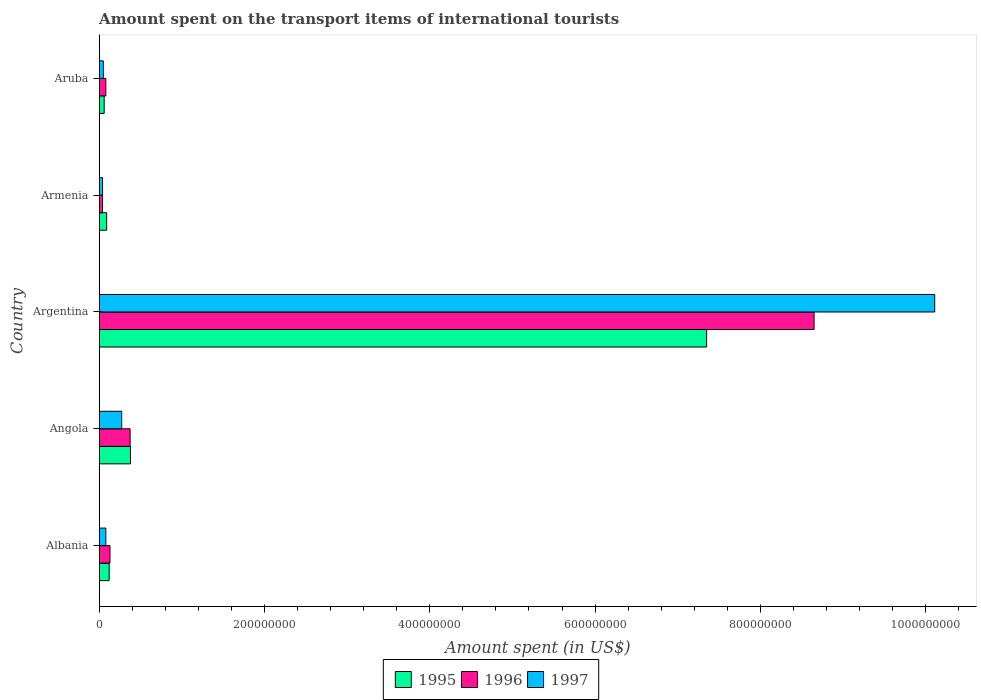How many groups of bars are there?
Offer a very short reply. 5. Are the number of bars per tick equal to the number of legend labels?
Your answer should be compact. Yes. How many bars are there on the 1st tick from the bottom?
Ensure brevity in your answer.  3. What is the label of the 5th group of bars from the top?
Ensure brevity in your answer.  Albania. In how many cases, is the number of bars for a given country not equal to the number of legend labels?
Keep it short and to the point. 0. What is the amount spent on the transport items of international tourists in 1996 in Aruba?
Give a very brief answer. 8.00e+06. Across all countries, what is the maximum amount spent on the transport items of international tourists in 1995?
Your answer should be very brief. 7.35e+08. In which country was the amount spent on the transport items of international tourists in 1995 maximum?
Make the answer very short. Argentina. In which country was the amount spent on the transport items of international tourists in 1997 minimum?
Your answer should be very brief. Armenia. What is the total amount spent on the transport items of international tourists in 1997 in the graph?
Provide a succinct answer. 1.06e+09. What is the average amount spent on the transport items of international tourists in 1997 per country?
Offer a very short reply. 2.11e+08. What is the difference between the amount spent on the transport items of international tourists in 1995 and amount spent on the transport items of international tourists in 1996 in Argentina?
Offer a terse response. -1.30e+08. What is the ratio of the amount spent on the transport items of international tourists in 1996 in Albania to that in Aruba?
Make the answer very short. 1.62. Is the difference between the amount spent on the transport items of international tourists in 1995 in Argentina and Aruba greater than the difference between the amount spent on the transport items of international tourists in 1996 in Argentina and Aruba?
Offer a terse response. No. What is the difference between the highest and the second highest amount spent on the transport items of international tourists in 1995?
Provide a short and direct response. 6.97e+08. What is the difference between the highest and the lowest amount spent on the transport items of international tourists in 1996?
Offer a terse response. 8.61e+08. Does the graph contain any zero values?
Make the answer very short. No. Does the graph contain grids?
Your answer should be compact. No. How are the legend labels stacked?
Offer a very short reply. Horizontal. What is the title of the graph?
Give a very brief answer. Amount spent on the transport items of international tourists. Does "1975" appear as one of the legend labels in the graph?
Make the answer very short. No. What is the label or title of the X-axis?
Your answer should be compact. Amount spent (in US$). What is the label or title of the Y-axis?
Your response must be concise. Country. What is the Amount spent (in US$) of 1995 in Albania?
Ensure brevity in your answer.  1.20e+07. What is the Amount spent (in US$) of 1996 in Albania?
Offer a terse response. 1.30e+07. What is the Amount spent (in US$) in 1997 in Albania?
Offer a terse response. 8.00e+06. What is the Amount spent (in US$) of 1995 in Angola?
Provide a succinct answer. 3.78e+07. What is the Amount spent (in US$) in 1996 in Angola?
Give a very brief answer. 3.74e+07. What is the Amount spent (in US$) in 1997 in Angola?
Offer a very short reply. 2.72e+07. What is the Amount spent (in US$) of 1995 in Argentina?
Give a very brief answer. 7.35e+08. What is the Amount spent (in US$) in 1996 in Argentina?
Keep it short and to the point. 8.65e+08. What is the Amount spent (in US$) in 1997 in Argentina?
Offer a very short reply. 1.01e+09. What is the Amount spent (in US$) in 1995 in Armenia?
Ensure brevity in your answer.  9.00e+06. What is the Amount spent (in US$) of 1996 in Armenia?
Provide a short and direct response. 4.00e+06. What is the Amount spent (in US$) of 1996 in Aruba?
Provide a succinct answer. 8.00e+06. Across all countries, what is the maximum Amount spent (in US$) of 1995?
Offer a very short reply. 7.35e+08. Across all countries, what is the maximum Amount spent (in US$) in 1996?
Provide a succinct answer. 8.65e+08. Across all countries, what is the maximum Amount spent (in US$) in 1997?
Offer a terse response. 1.01e+09. What is the total Amount spent (in US$) of 1995 in the graph?
Ensure brevity in your answer.  8.00e+08. What is the total Amount spent (in US$) in 1996 in the graph?
Provide a succinct answer. 9.27e+08. What is the total Amount spent (in US$) in 1997 in the graph?
Keep it short and to the point. 1.06e+09. What is the difference between the Amount spent (in US$) in 1995 in Albania and that in Angola?
Ensure brevity in your answer.  -2.58e+07. What is the difference between the Amount spent (in US$) in 1996 in Albania and that in Angola?
Ensure brevity in your answer.  -2.44e+07. What is the difference between the Amount spent (in US$) in 1997 in Albania and that in Angola?
Provide a succinct answer. -1.92e+07. What is the difference between the Amount spent (in US$) of 1995 in Albania and that in Argentina?
Ensure brevity in your answer.  -7.23e+08. What is the difference between the Amount spent (in US$) in 1996 in Albania and that in Argentina?
Give a very brief answer. -8.52e+08. What is the difference between the Amount spent (in US$) of 1997 in Albania and that in Argentina?
Your answer should be very brief. -1.00e+09. What is the difference between the Amount spent (in US$) of 1996 in Albania and that in Armenia?
Ensure brevity in your answer.  9.00e+06. What is the difference between the Amount spent (in US$) of 1995 in Angola and that in Argentina?
Ensure brevity in your answer.  -6.97e+08. What is the difference between the Amount spent (in US$) of 1996 in Angola and that in Argentina?
Make the answer very short. -8.28e+08. What is the difference between the Amount spent (in US$) of 1997 in Angola and that in Argentina?
Provide a succinct answer. -9.84e+08. What is the difference between the Amount spent (in US$) of 1995 in Angola and that in Armenia?
Make the answer very short. 2.88e+07. What is the difference between the Amount spent (in US$) in 1996 in Angola and that in Armenia?
Your response must be concise. 3.34e+07. What is the difference between the Amount spent (in US$) of 1997 in Angola and that in Armenia?
Your answer should be very brief. 2.32e+07. What is the difference between the Amount spent (in US$) in 1995 in Angola and that in Aruba?
Your answer should be very brief. 3.18e+07. What is the difference between the Amount spent (in US$) in 1996 in Angola and that in Aruba?
Your answer should be very brief. 2.94e+07. What is the difference between the Amount spent (in US$) in 1997 in Angola and that in Aruba?
Give a very brief answer. 2.22e+07. What is the difference between the Amount spent (in US$) of 1995 in Argentina and that in Armenia?
Make the answer very short. 7.26e+08. What is the difference between the Amount spent (in US$) of 1996 in Argentina and that in Armenia?
Provide a short and direct response. 8.61e+08. What is the difference between the Amount spent (in US$) of 1997 in Argentina and that in Armenia?
Give a very brief answer. 1.01e+09. What is the difference between the Amount spent (in US$) of 1995 in Argentina and that in Aruba?
Keep it short and to the point. 7.29e+08. What is the difference between the Amount spent (in US$) in 1996 in Argentina and that in Aruba?
Your answer should be very brief. 8.57e+08. What is the difference between the Amount spent (in US$) of 1997 in Argentina and that in Aruba?
Make the answer very short. 1.01e+09. What is the difference between the Amount spent (in US$) in 1995 in Armenia and that in Aruba?
Provide a succinct answer. 3.00e+06. What is the difference between the Amount spent (in US$) in 1996 in Armenia and that in Aruba?
Offer a very short reply. -4.00e+06. What is the difference between the Amount spent (in US$) in 1997 in Armenia and that in Aruba?
Keep it short and to the point. -1.00e+06. What is the difference between the Amount spent (in US$) of 1995 in Albania and the Amount spent (in US$) of 1996 in Angola?
Give a very brief answer. -2.54e+07. What is the difference between the Amount spent (in US$) in 1995 in Albania and the Amount spent (in US$) in 1997 in Angola?
Your answer should be compact. -1.52e+07. What is the difference between the Amount spent (in US$) of 1996 in Albania and the Amount spent (in US$) of 1997 in Angola?
Make the answer very short. -1.42e+07. What is the difference between the Amount spent (in US$) of 1995 in Albania and the Amount spent (in US$) of 1996 in Argentina?
Ensure brevity in your answer.  -8.53e+08. What is the difference between the Amount spent (in US$) of 1995 in Albania and the Amount spent (in US$) of 1997 in Argentina?
Provide a succinct answer. -9.99e+08. What is the difference between the Amount spent (in US$) of 1996 in Albania and the Amount spent (in US$) of 1997 in Argentina?
Your answer should be very brief. -9.98e+08. What is the difference between the Amount spent (in US$) of 1995 in Albania and the Amount spent (in US$) of 1997 in Armenia?
Make the answer very short. 8.00e+06. What is the difference between the Amount spent (in US$) in 1996 in Albania and the Amount spent (in US$) in 1997 in Armenia?
Offer a very short reply. 9.00e+06. What is the difference between the Amount spent (in US$) of 1995 in Albania and the Amount spent (in US$) of 1997 in Aruba?
Your response must be concise. 7.00e+06. What is the difference between the Amount spent (in US$) in 1996 in Albania and the Amount spent (in US$) in 1997 in Aruba?
Provide a succinct answer. 8.00e+06. What is the difference between the Amount spent (in US$) in 1995 in Angola and the Amount spent (in US$) in 1996 in Argentina?
Ensure brevity in your answer.  -8.27e+08. What is the difference between the Amount spent (in US$) of 1995 in Angola and the Amount spent (in US$) of 1997 in Argentina?
Ensure brevity in your answer.  -9.73e+08. What is the difference between the Amount spent (in US$) in 1996 in Angola and the Amount spent (in US$) in 1997 in Argentina?
Ensure brevity in your answer.  -9.74e+08. What is the difference between the Amount spent (in US$) of 1995 in Angola and the Amount spent (in US$) of 1996 in Armenia?
Provide a short and direct response. 3.38e+07. What is the difference between the Amount spent (in US$) of 1995 in Angola and the Amount spent (in US$) of 1997 in Armenia?
Offer a terse response. 3.38e+07. What is the difference between the Amount spent (in US$) of 1996 in Angola and the Amount spent (in US$) of 1997 in Armenia?
Provide a succinct answer. 3.34e+07. What is the difference between the Amount spent (in US$) of 1995 in Angola and the Amount spent (in US$) of 1996 in Aruba?
Your response must be concise. 2.98e+07. What is the difference between the Amount spent (in US$) of 1995 in Angola and the Amount spent (in US$) of 1997 in Aruba?
Give a very brief answer. 3.28e+07. What is the difference between the Amount spent (in US$) in 1996 in Angola and the Amount spent (in US$) in 1997 in Aruba?
Provide a succinct answer. 3.24e+07. What is the difference between the Amount spent (in US$) of 1995 in Argentina and the Amount spent (in US$) of 1996 in Armenia?
Your answer should be very brief. 7.31e+08. What is the difference between the Amount spent (in US$) of 1995 in Argentina and the Amount spent (in US$) of 1997 in Armenia?
Your answer should be very brief. 7.31e+08. What is the difference between the Amount spent (in US$) in 1996 in Argentina and the Amount spent (in US$) in 1997 in Armenia?
Keep it short and to the point. 8.61e+08. What is the difference between the Amount spent (in US$) of 1995 in Argentina and the Amount spent (in US$) of 1996 in Aruba?
Ensure brevity in your answer.  7.27e+08. What is the difference between the Amount spent (in US$) in 1995 in Argentina and the Amount spent (in US$) in 1997 in Aruba?
Keep it short and to the point. 7.30e+08. What is the difference between the Amount spent (in US$) of 1996 in Argentina and the Amount spent (in US$) of 1997 in Aruba?
Offer a terse response. 8.60e+08. What is the difference between the Amount spent (in US$) in 1995 in Armenia and the Amount spent (in US$) in 1996 in Aruba?
Offer a very short reply. 1.00e+06. What is the difference between the Amount spent (in US$) in 1996 in Armenia and the Amount spent (in US$) in 1997 in Aruba?
Provide a short and direct response. -1.00e+06. What is the average Amount spent (in US$) of 1995 per country?
Your answer should be very brief. 1.60e+08. What is the average Amount spent (in US$) in 1996 per country?
Keep it short and to the point. 1.85e+08. What is the average Amount spent (in US$) in 1997 per country?
Make the answer very short. 2.11e+08. What is the difference between the Amount spent (in US$) in 1995 and Amount spent (in US$) in 1997 in Albania?
Provide a succinct answer. 4.00e+06. What is the difference between the Amount spent (in US$) of 1995 and Amount spent (in US$) of 1996 in Angola?
Provide a succinct answer. 4.50e+05. What is the difference between the Amount spent (in US$) of 1995 and Amount spent (in US$) of 1997 in Angola?
Provide a short and direct response. 1.06e+07. What is the difference between the Amount spent (in US$) of 1996 and Amount spent (in US$) of 1997 in Angola?
Ensure brevity in your answer.  1.02e+07. What is the difference between the Amount spent (in US$) of 1995 and Amount spent (in US$) of 1996 in Argentina?
Make the answer very short. -1.30e+08. What is the difference between the Amount spent (in US$) in 1995 and Amount spent (in US$) in 1997 in Argentina?
Your answer should be compact. -2.76e+08. What is the difference between the Amount spent (in US$) in 1996 and Amount spent (in US$) in 1997 in Argentina?
Provide a short and direct response. -1.46e+08. What is the difference between the Amount spent (in US$) in 1995 and Amount spent (in US$) in 1997 in Aruba?
Provide a short and direct response. 1.00e+06. What is the difference between the Amount spent (in US$) of 1996 and Amount spent (in US$) of 1997 in Aruba?
Give a very brief answer. 3.00e+06. What is the ratio of the Amount spent (in US$) of 1995 in Albania to that in Angola?
Offer a very short reply. 0.32. What is the ratio of the Amount spent (in US$) of 1996 in Albania to that in Angola?
Provide a short and direct response. 0.35. What is the ratio of the Amount spent (in US$) of 1997 in Albania to that in Angola?
Ensure brevity in your answer.  0.29. What is the ratio of the Amount spent (in US$) in 1995 in Albania to that in Argentina?
Make the answer very short. 0.02. What is the ratio of the Amount spent (in US$) in 1996 in Albania to that in Argentina?
Your response must be concise. 0.01. What is the ratio of the Amount spent (in US$) in 1997 in Albania to that in Argentina?
Your response must be concise. 0.01. What is the ratio of the Amount spent (in US$) in 1995 in Albania to that in Armenia?
Give a very brief answer. 1.33. What is the ratio of the Amount spent (in US$) in 1996 in Albania to that in Armenia?
Your response must be concise. 3.25. What is the ratio of the Amount spent (in US$) in 1997 in Albania to that in Armenia?
Make the answer very short. 2. What is the ratio of the Amount spent (in US$) of 1995 in Albania to that in Aruba?
Your answer should be very brief. 2. What is the ratio of the Amount spent (in US$) of 1996 in Albania to that in Aruba?
Your answer should be very brief. 1.62. What is the ratio of the Amount spent (in US$) in 1995 in Angola to that in Argentina?
Keep it short and to the point. 0.05. What is the ratio of the Amount spent (in US$) in 1996 in Angola to that in Argentina?
Provide a short and direct response. 0.04. What is the ratio of the Amount spent (in US$) of 1997 in Angola to that in Argentina?
Offer a very short reply. 0.03. What is the ratio of the Amount spent (in US$) in 1995 in Angola to that in Armenia?
Your answer should be very brief. 4.2. What is the ratio of the Amount spent (in US$) of 1996 in Angola to that in Armenia?
Your response must be concise. 9.34. What is the ratio of the Amount spent (in US$) of 1997 in Angola to that in Armenia?
Offer a very short reply. 6.8. What is the ratio of the Amount spent (in US$) of 1995 in Angola to that in Aruba?
Provide a succinct answer. 6.3. What is the ratio of the Amount spent (in US$) in 1996 in Angola to that in Aruba?
Provide a short and direct response. 4.67. What is the ratio of the Amount spent (in US$) of 1997 in Angola to that in Aruba?
Your answer should be very brief. 5.44. What is the ratio of the Amount spent (in US$) of 1995 in Argentina to that in Armenia?
Provide a succinct answer. 81.67. What is the ratio of the Amount spent (in US$) of 1996 in Argentina to that in Armenia?
Offer a very short reply. 216.25. What is the ratio of the Amount spent (in US$) in 1997 in Argentina to that in Armenia?
Keep it short and to the point. 252.75. What is the ratio of the Amount spent (in US$) of 1995 in Argentina to that in Aruba?
Your response must be concise. 122.5. What is the ratio of the Amount spent (in US$) in 1996 in Argentina to that in Aruba?
Provide a short and direct response. 108.12. What is the ratio of the Amount spent (in US$) in 1997 in Argentina to that in Aruba?
Provide a succinct answer. 202.2. What is the ratio of the Amount spent (in US$) of 1995 in Armenia to that in Aruba?
Provide a short and direct response. 1.5. What is the ratio of the Amount spent (in US$) in 1997 in Armenia to that in Aruba?
Provide a short and direct response. 0.8. What is the difference between the highest and the second highest Amount spent (in US$) of 1995?
Your response must be concise. 6.97e+08. What is the difference between the highest and the second highest Amount spent (in US$) of 1996?
Provide a short and direct response. 8.28e+08. What is the difference between the highest and the second highest Amount spent (in US$) of 1997?
Offer a terse response. 9.84e+08. What is the difference between the highest and the lowest Amount spent (in US$) of 1995?
Provide a short and direct response. 7.29e+08. What is the difference between the highest and the lowest Amount spent (in US$) in 1996?
Provide a succinct answer. 8.61e+08. What is the difference between the highest and the lowest Amount spent (in US$) in 1997?
Offer a terse response. 1.01e+09. 